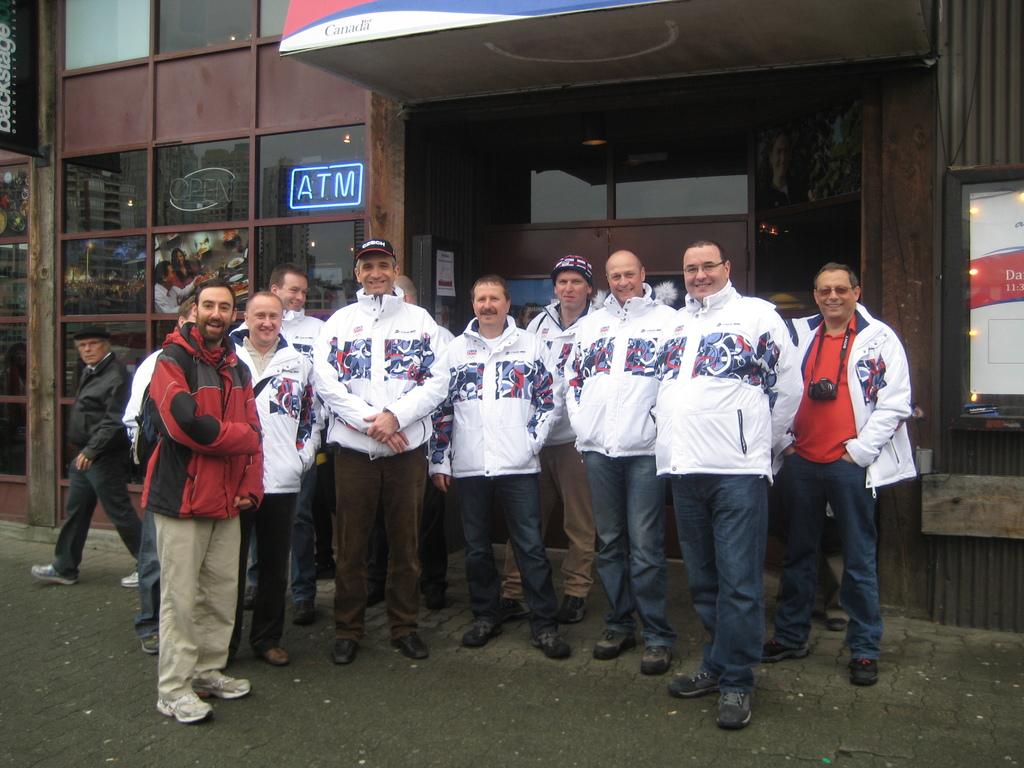What does the blue neon sign say?
Your answer should be compact. Atm. What country is written on the awning above the people?
Keep it short and to the point. Canada. 